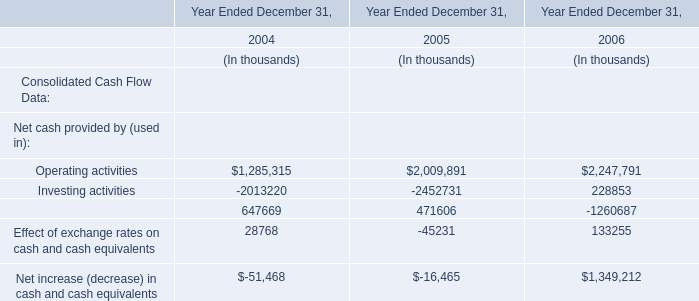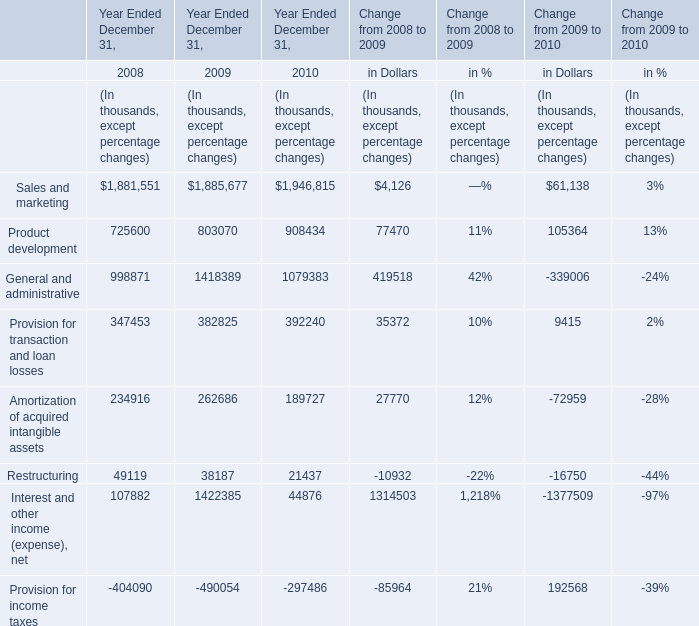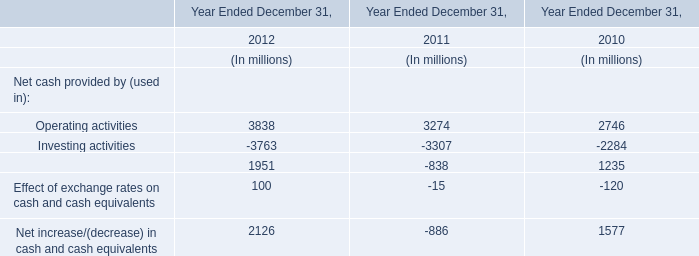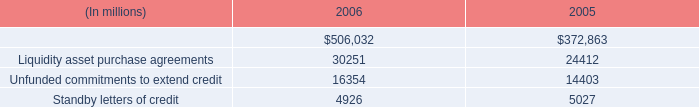what is the total of credit-related financial instruments in 2006? ( $ ) 
Computations: (((506032 + 30251) + 16354) + 4926)
Answer: 557563.0. 